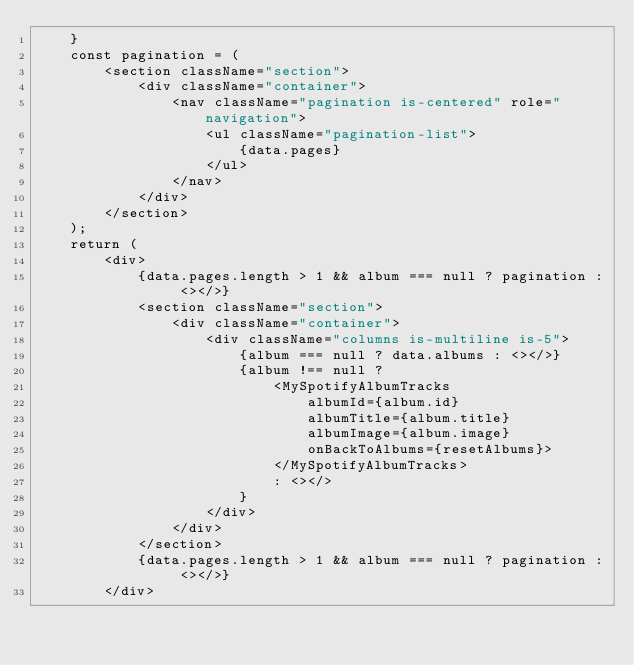Convert code to text. <code><loc_0><loc_0><loc_500><loc_500><_JavaScript_>    }
    const pagination = (
        <section className="section">
            <div className="container">
                <nav className="pagination is-centered" role="navigation">
                    <ul className="pagination-list">
                        {data.pages}
                    </ul>
                </nav>
            </div>
        </section>
    );
    return (
        <div>
            {data.pages.length > 1 && album === null ? pagination : <></>}
            <section className="section">
                <div className="container">
                    <div className="columns is-multiline is-5">
                        {album === null ? data.albums : <></>}
                        {album !== null ?
                            <MySpotifyAlbumTracks
                                albumId={album.id}
                                albumTitle={album.title}
                                albumImage={album.image}
                                onBackToAlbums={resetAlbums}>
                            </MySpotifyAlbumTracks>
                            : <></>
                        }
                    </div>
                </div>
            </section>
            {data.pages.length > 1 && album === null ? pagination : <></>}
        </div></code> 